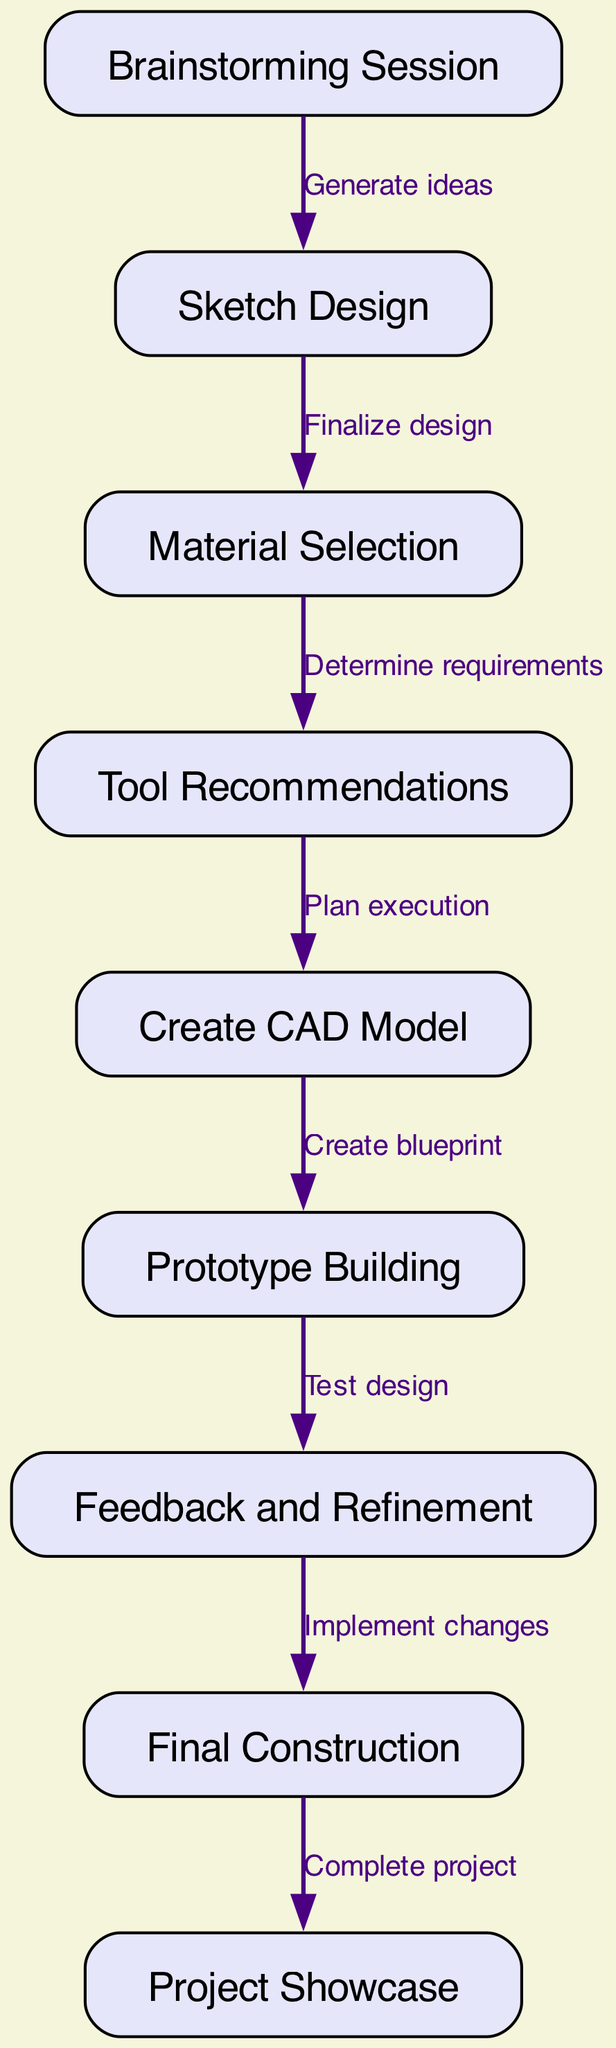What is the first step in the workflow? The first step is indicated by the starting node, which is "Brainstorming Session". This is the initial stage of the process where ideas are generated.
Answer: Brainstorming Session How many nodes are in the diagram? To determine the number of nodes, we count all the distinct steps represented in the diagram. There are 9 nodes listed in total.
Answer: 9 What step comes after "Material Selection"? By examining the flow of the diagram, "Tool Recommendations" directly follows "Material Selection" as indicated by the connecting edge.
Answer: Tool Recommendations Which step involves "testing design"? The node that represents the action of testing the design is "Prototype Building", as it leads to obtaining feedback for refinement.
Answer: Prototype Building What is the last step before project showcase? Looking at the diagram, the last step before "Project Showcase" is "Final Construction". This is where the actual building of the project takes place prior to showcasing it.
Answer: Final Construction Describe the connection between "Sketch Design" and "Material Selection." The edge that connects "Sketch Design" to "Material Selection" indicates that after finalizing the design in "Sketch Design," the next step is to choose the materials, which is reflected in the connection labeled "Finalize design".
Answer: Finalize design How many edges are in the diagram? The edges represent the connections between the nodes, and by counting them, we find a total of 8 edges in the workflow.
Answer: 8 What is the relationship between "Feedback and Refinement" and "Final Construction"? The relationship shows that feedback from the prototype is used to implement changes before moving on to "Final Construction," indicating a direct dependency on refining the design before completing the project.
Answer: Implement changes 